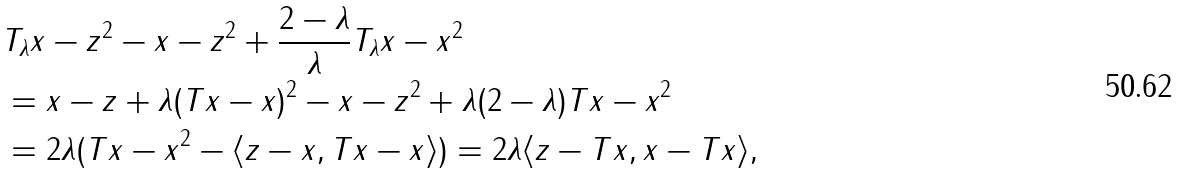<formula> <loc_0><loc_0><loc_500><loc_500>& \| T _ { \lambda } x - z \| ^ { 2 } - \| x - z \| ^ { 2 } + \frac { 2 - \lambda } { \lambda } \| T _ { \lambda } x - x \| ^ { 2 } \\ & = \| x - z + \lambda ( T x - x ) \| ^ { 2 } - \| x - z \| ^ { 2 } + \lambda ( 2 - \lambda ) \| T x - x \| ^ { 2 } \\ & = 2 \lambda ( \| T x - x \| ^ { 2 } - \langle z - x , T x - x \rangle ) = 2 \lambda \langle z - T x , x - T x \rangle ,</formula> 